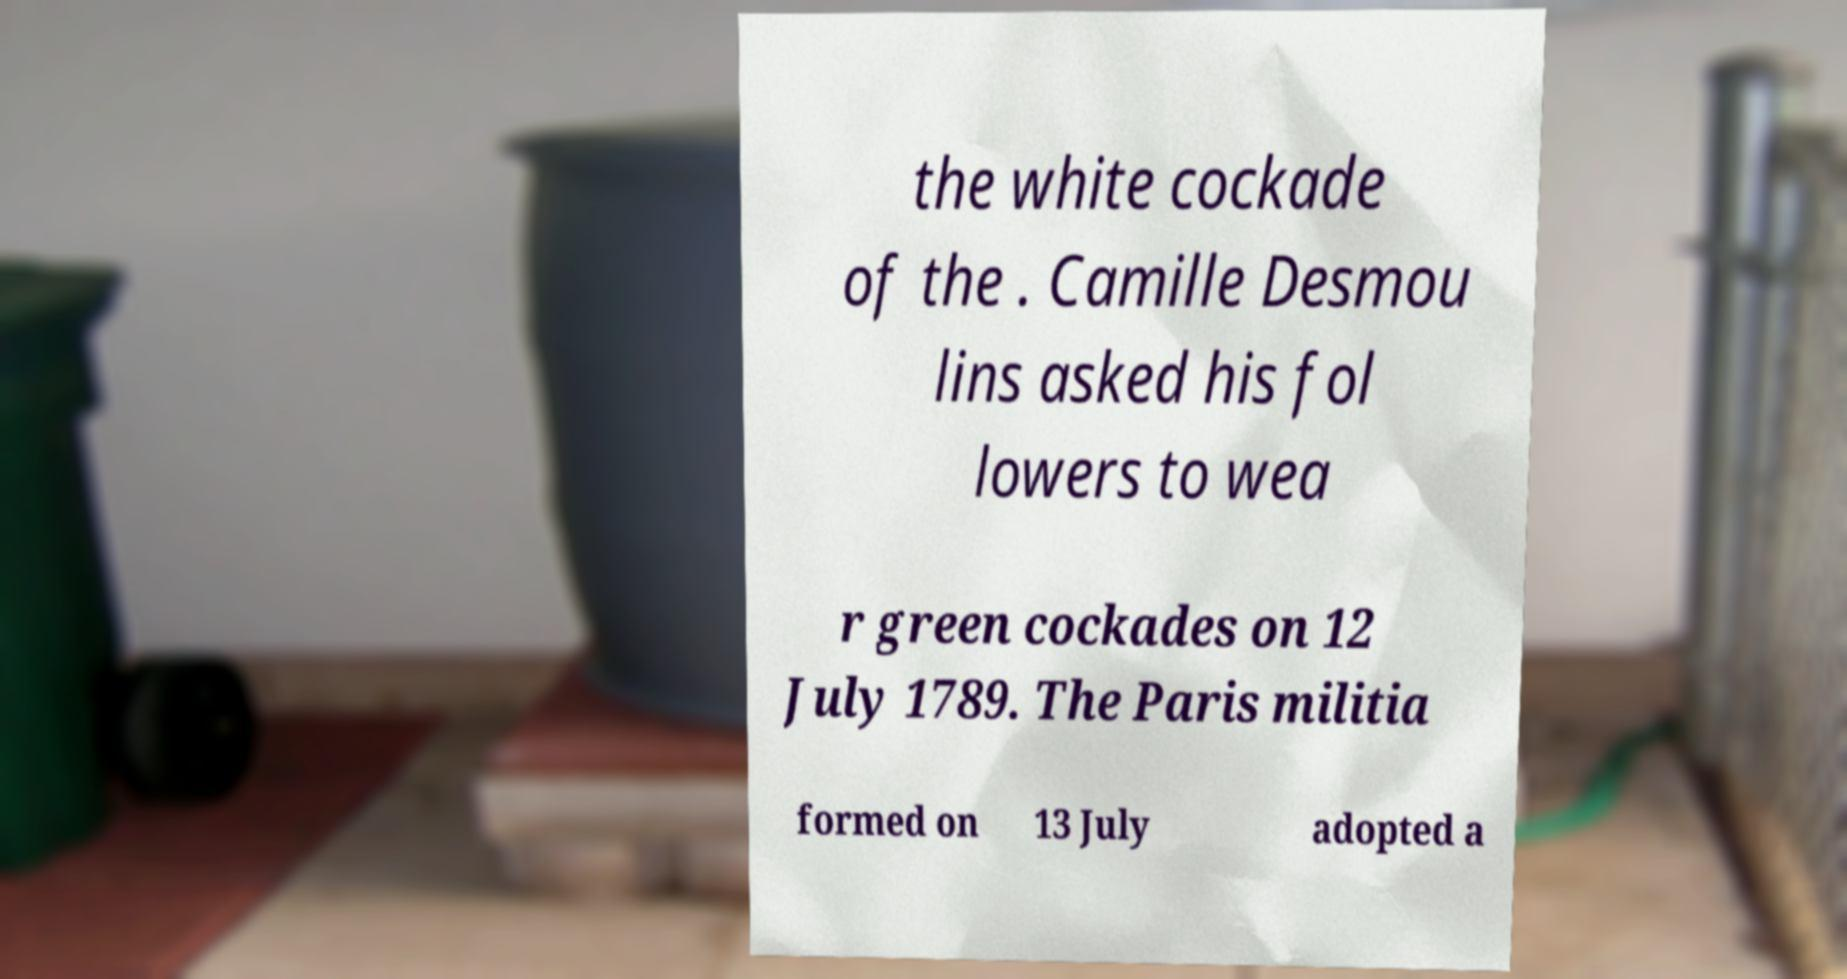Please read and relay the text visible in this image. What does it say? the white cockade of the . Camille Desmou lins asked his fol lowers to wea r green cockades on 12 July 1789. The Paris militia formed on 13 July adopted a 